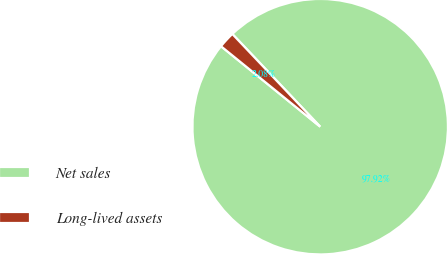Convert chart to OTSL. <chart><loc_0><loc_0><loc_500><loc_500><pie_chart><fcel>Net sales<fcel>Long-lived assets<nl><fcel>97.92%<fcel>2.08%<nl></chart> 